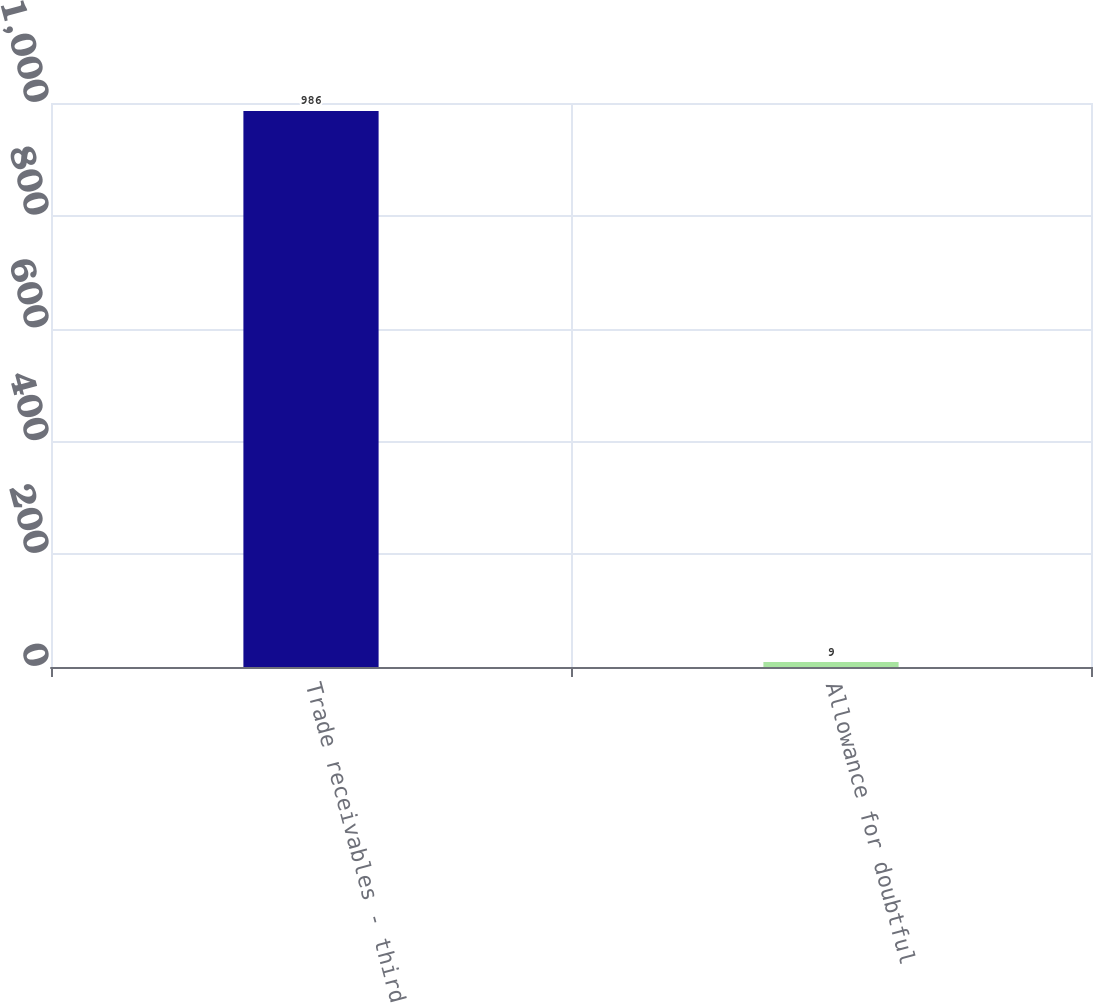Convert chart to OTSL. <chart><loc_0><loc_0><loc_500><loc_500><bar_chart><fcel>Trade receivables - third<fcel>Allowance for doubtful<nl><fcel>986<fcel>9<nl></chart> 